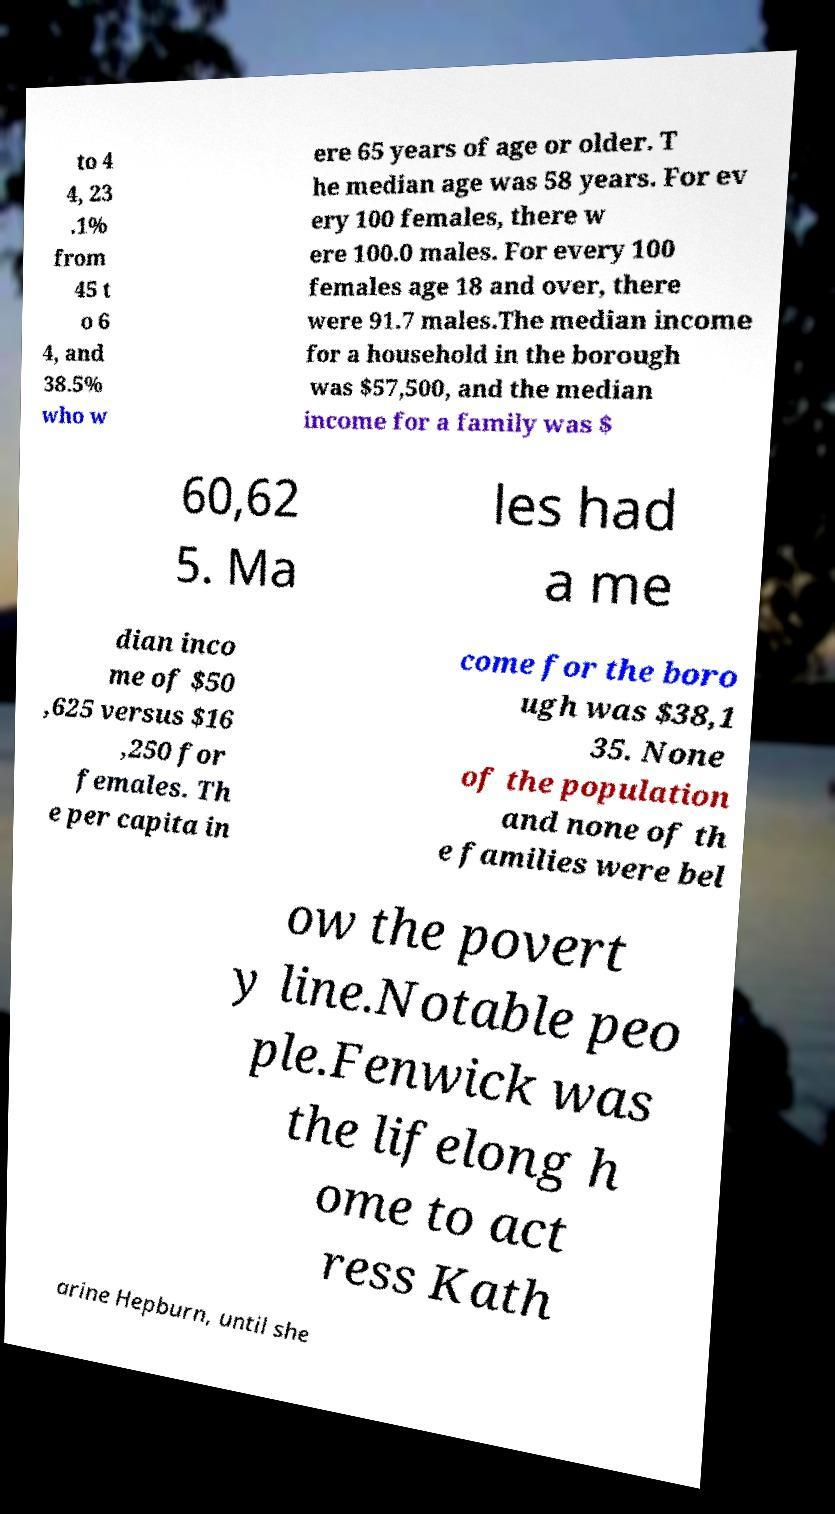I need the written content from this picture converted into text. Can you do that? to 4 4, 23 .1% from 45 t o 6 4, and 38.5% who w ere 65 years of age or older. T he median age was 58 years. For ev ery 100 females, there w ere 100.0 males. For every 100 females age 18 and over, there were 91.7 males.The median income for a household in the borough was $57,500, and the median income for a family was $ 60,62 5. Ma les had a me dian inco me of $50 ,625 versus $16 ,250 for females. Th e per capita in come for the boro ugh was $38,1 35. None of the population and none of th e families were bel ow the povert y line.Notable peo ple.Fenwick was the lifelong h ome to act ress Kath arine Hepburn, until she 